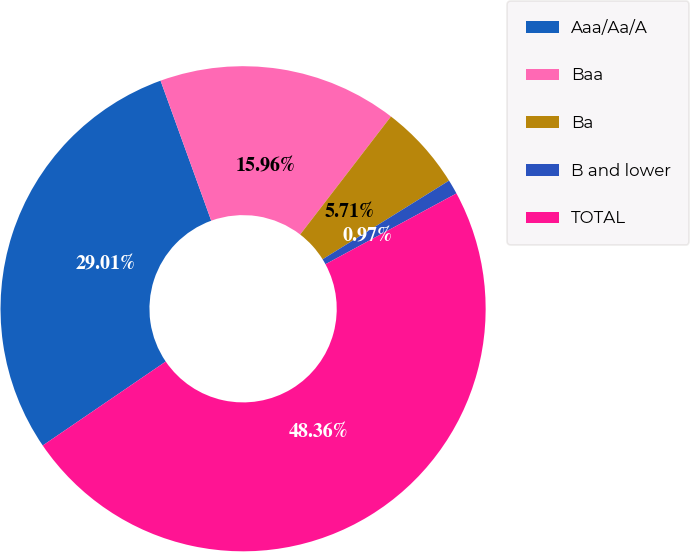<chart> <loc_0><loc_0><loc_500><loc_500><pie_chart><fcel>Aaa/Aa/A<fcel>Baa<fcel>Ba<fcel>B and lower<fcel>TOTAL<nl><fcel>29.01%<fcel>15.96%<fcel>5.71%<fcel>0.97%<fcel>48.36%<nl></chart> 